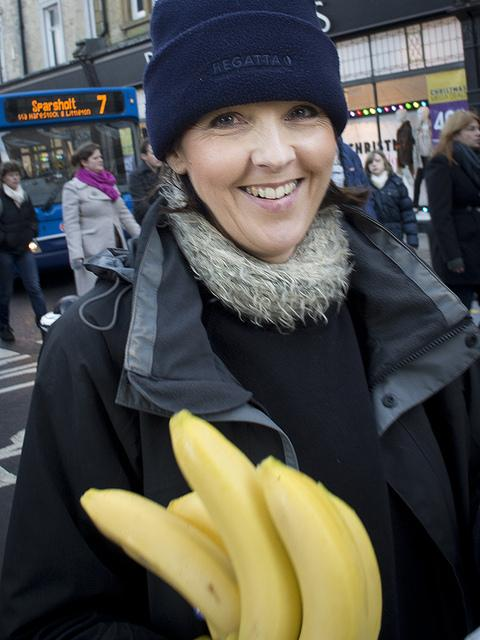The store behind the bus is having a sale due to which major event? christmas 